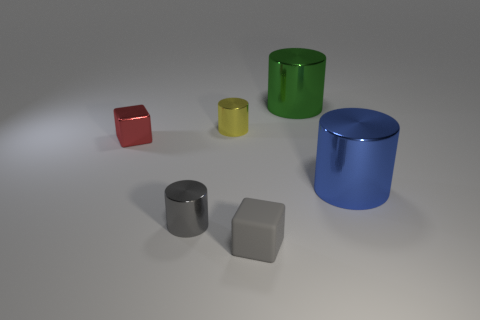What is the color of the block that is behind the gray block?
Provide a succinct answer. Red. What is the material of the cylinder that is the same color as the tiny matte thing?
Your response must be concise. Metal. Is there a rubber object that has the same shape as the blue metallic thing?
Offer a terse response. No. What number of gray things have the same shape as the small yellow thing?
Your response must be concise. 1. Do the small shiny block and the matte block have the same color?
Ensure brevity in your answer.  No. Is the number of gray shiny objects less than the number of large cyan objects?
Ensure brevity in your answer.  No. There is a tiny gray object to the right of the yellow cylinder; what is its material?
Offer a very short reply. Rubber. What is the material of the red thing that is the same size as the yellow shiny cylinder?
Give a very brief answer. Metal. What material is the cylinder in front of the cylinder that is to the right of the large metallic object that is left of the blue metal thing?
Your response must be concise. Metal. There is a shiny object to the right of the green shiny object; does it have the same size as the big green cylinder?
Provide a succinct answer. Yes. 